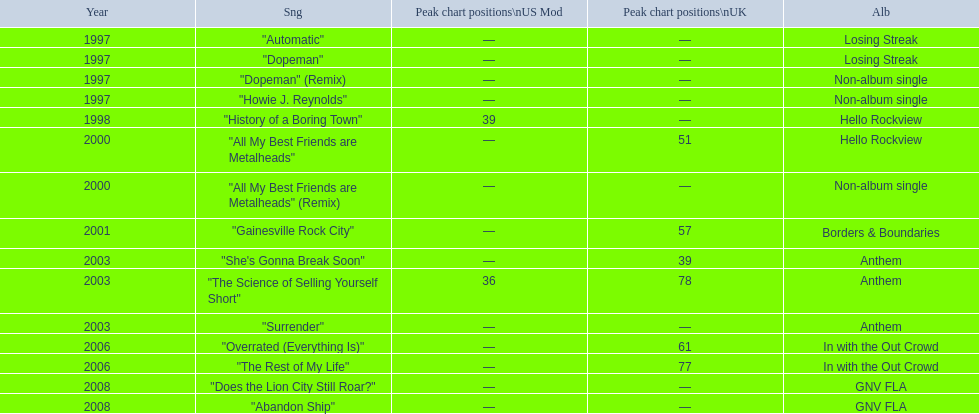Which single was released before "dopeman"? "Automatic". 